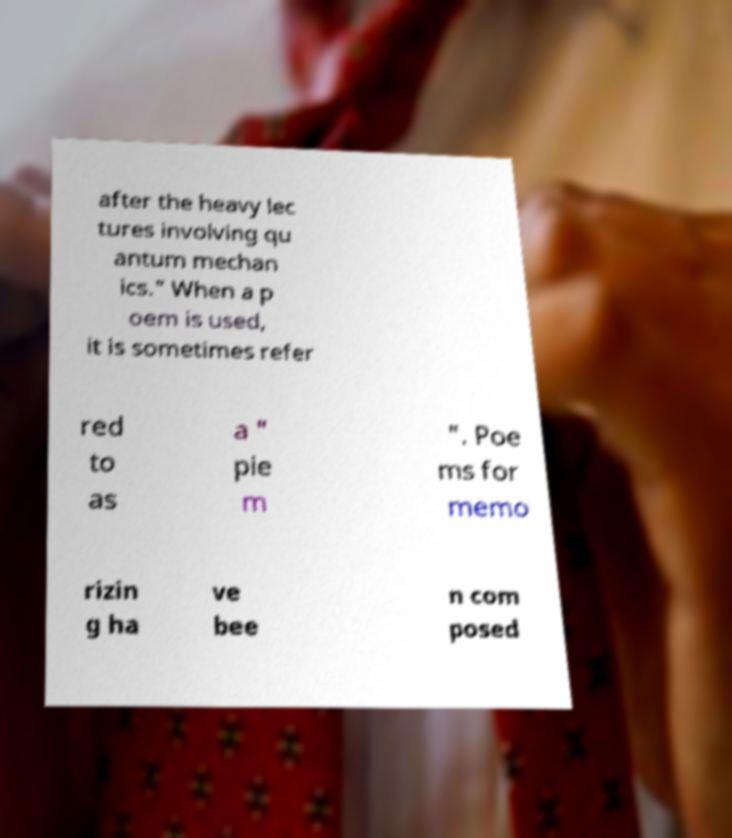Please read and relay the text visible in this image. What does it say? after the heavy lec tures involving qu antum mechan ics." When a p oem is used, it is sometimes refer red to as a " pie m ". Poe ms for memo rizin g ha ve bee n com posed 